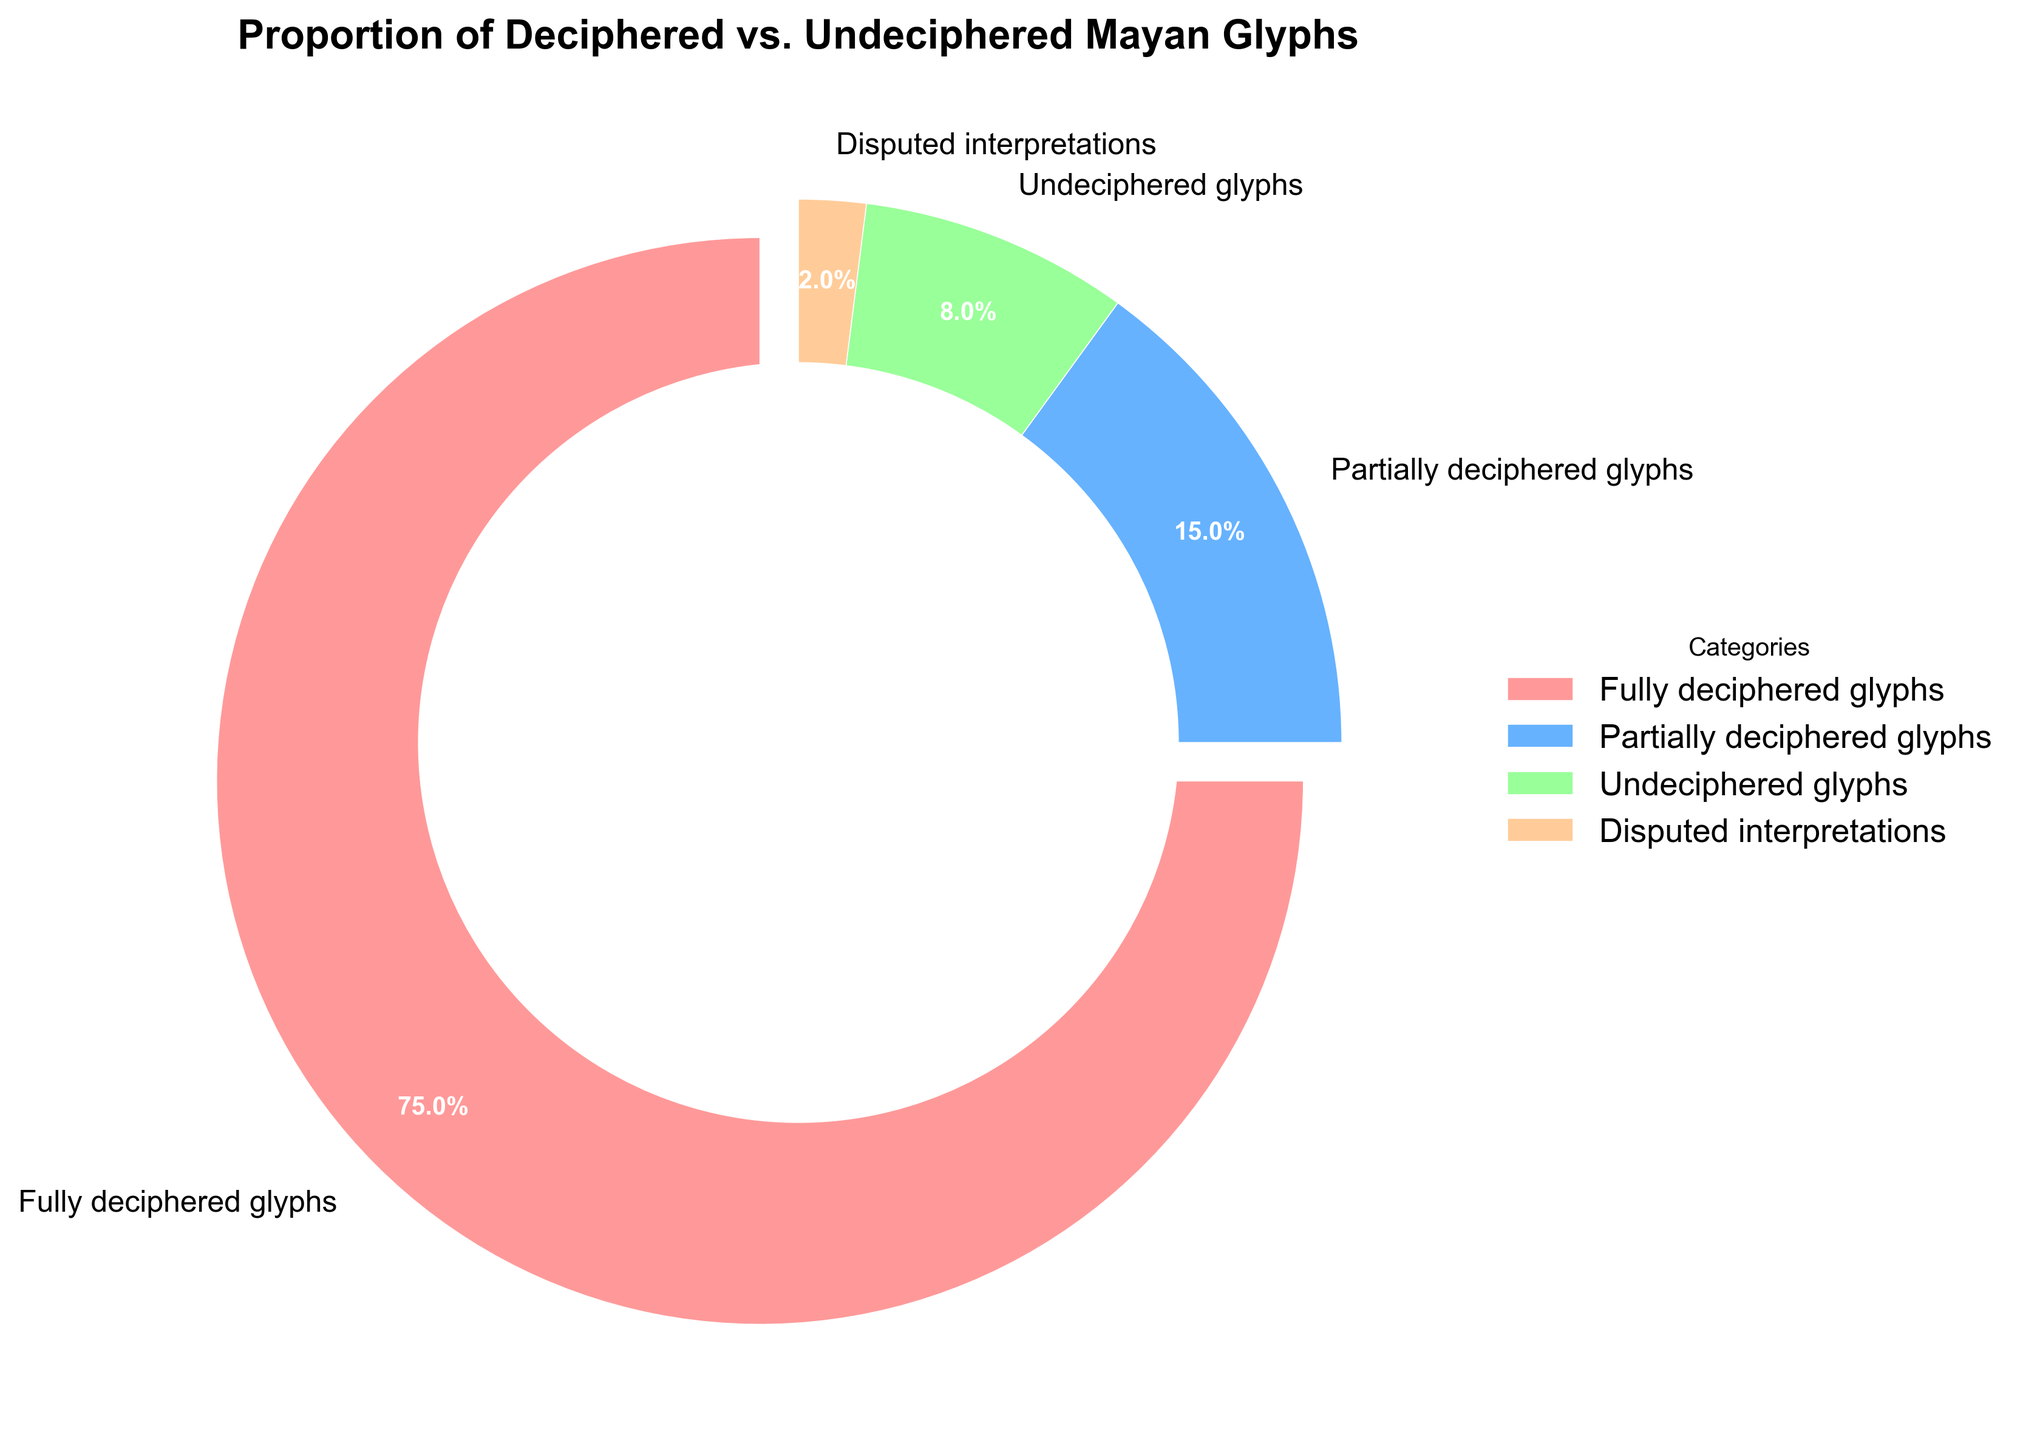What is the proportion of fully deciphered glyphs? To find the proportion of fully deciphered glyphs, look at the corresponding section in the pie chart. It is labeled as "Fully deciphered glyphs" and has a value indicating 75%.
Answer: 75% What is the sum of the percentages for partially deciphered and undeciphered glyphs? First, identify the percentages for partially deciphered glyphs (15%) and undeciphered glyphs (8%) from the pie chart. Then, add these two values together: 15% + 8% = 23%.
Answer: 23% Which category has the least representation in the pie chart? Identify the smallest slice in the pie chart. The slice labeled "Disputed interpretations" has the smallest percentage at 2%.
Answer: Disputed interpretations How much larger is the proportion of fully deciphered glyphs compared to disputed interpretations? Find the percentage for fully deciphered glyphs (75%) and disputed interpretations (2%). Subtract the smaller percentage from the larger one: 75% - 2% = 73%.
Answer: 73% What is the combined percentage of fully deciphered and disputed interpretations glyphs? Add the percentages for fully deciphered glyphs (75%) and disputed interpretations (2%): 75% + 2% = 77%.
Answer: 77% Which categories together make up less than 50% of the total? Identify the categories and their percentages: partially deciphered glyphs (15%), undeciphered glyphs (8%), and disputed interpretations (2%). Add these values to see if their total is less than 50%: 15% + 8% + 2% = 25%.
Answer: Partially deciphered glyphs, Undeciphered glyphs, Disputed interpretations Are the partially deciphered glyphs more or less than half of the fully deciphered glyphs? Compare the percentages: partially deciphered glyphs (15%) and fully deciphered glyphs (75%). Calculate half of fully deciphered glyphs: 75% / 2 = 37.5%. Since 15% is less than 37.5%, partially deciphered glyphs are less than half of fully deciphered glyphs.
Answer: Less What's the ratio of fully deciphered glyphs to undeciphered glyphs? Find the percentages for fully deciphered glyphs (75%) and undeciphered glyphs (8%). Then, calculate the ratio: 75% / 8% = 9.375.
Answer: 9.375 What is the percentage difference between partially deciphered glyphs and undeciphered glyphs? Subtract the percentage of undeciphered glyphs (8%) from the percentage of partially deciphered glyphs (15%): 15% - 8% = 7%.
Answer: 7% What color is the section representing the undeciphered glyphs? Examine the pie chart's color-coded sections. The section labeled "Undeciphered glyphs" is colored green.
Answer: Green 